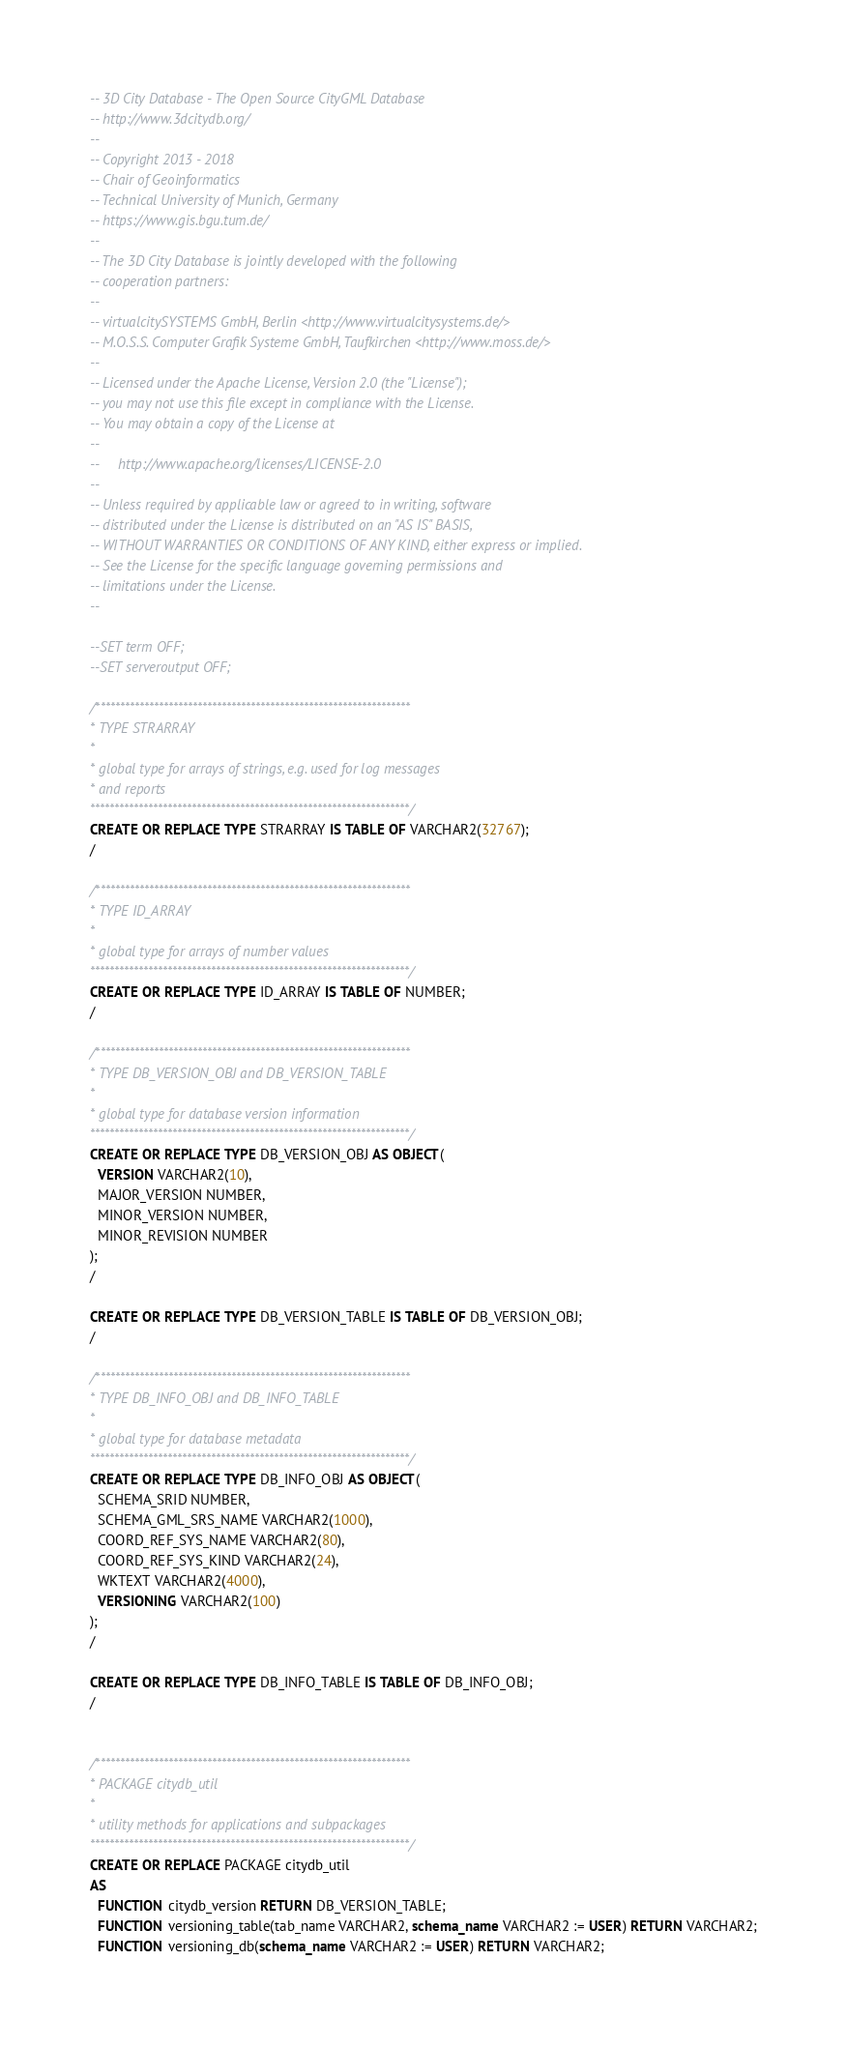<code> <loc_0><loc_0><loc_500><loc_500><_SQL_>-- 3D City Database - The Open Source CityGML Database
-- http://www.3dcitydb.org/
-- 
-- Copyright 2013 - 2018
-- Chair of Geoinformatics
-- Technical University of Munich, Germany
-- https://www.gis.bgu.tum.de/
-- 
-- The 3D City Database is jointly developed with the following
-- cooperation partners:
-- 
-- virtualcitySYSTEMS GmbH, Berlin <http://www.virtualcitysystems.de/>
-- M.O.S.S. Computer Grafik Systeme GmbH, Taufkirchen <http://www.moss.de/>
-- 
-- Licensed under the Apache License, Version 2.0 (the "License");
-- you may not use this file except in compliance with the License.
-- You may obtain a copy of the License at
-- 
--     http://www.apache.org/licenses/LICENSE-2.0
--     
-- Unless required by applicable law or agreed to in writing, software
-- distributed under the License is distributed on an "AS IS" BASIS,
-- WITHOUT WARRANTIES OR CONDITIONS OF ANY KIND, either express or implied.
-- See the License for the specific language governing permissions and
-- limitations under the License.
--

--SET term OFF;
--SET serveroutput OFF;

/*****************************************************************
* TYPE STRARRAY
*
* global type for arrays of strings, e.g. used for log messages
* and reports
******************************************************************/
CREATE OR REPLACE TYPE STRARRAY IS TABLE OF VARCHAR2(32767);
/

/*****************************************************************
* TYPE ID_ARRAY
*
* global type for arrays of number values
******************************************************************/
CREATE OR REPLACE TYPE ID_ARRAY IS TABLE OF NUMBER;
/

/*****************************************************************
* TYPE DB_VERSION_OBJ and DB_VERSION_TABLE
* 
* global type for database version information
******************************************************************/
CREATE OR REPLACE TYPE DB_VERSION_OBJ AS OBJECT(
  VERSION VARCHAR2(10),
  MAJOR_VERSION NUMBER,
  MINOR_VERSION NUMBER,
  MINOR_REVISION NUMBER
);
/

CREATE OR REPLACE TYPE DB_VERSION_TABLE IS TABLE OF DB_VERSION_OBJ;
/

/*****************************************************************
* TYPE DB_INFO_OBJ and DB_INFO_TABLE
* 
* global type for database metadata
******************************************************************/
CREATE OR REPLACE TYPE DB_INFO_OBJ AS OBJECT(
  SCHEMA_SRID NUMBER,
  SCHEMA_GML_SRS_NAME VARCHAR2(1000),
  COORD_REF_SYS_NAME VARCHAR2(80),
  COORD_REF_SYS_KIND VARCHAR2(24),
  WKTEXT VARCHAR2(4000),
  VERSIONING VARCHAR2(100)
);
/

CREATE OR REPLACE TYPE DB_INFO_TABLE IS TABLE OF DB_INFO_OBJ;
/


/*****************************************************************
* PACKAGE citydb_util
* 
* utility methods for applications and subpackages
******************************************************************/
CREATE OR REPLACE PACKAGE citydb_util
AS
  FUNCTION citydb_version RETURN DB_VERSION_TABLE;
  FUNCTION versioning_table(tab_name VARCHAR2, schema_name VARCHAR2 := USER) RETURN VARCHAR2;
  FUNCTION versioning_db(schema_name VARCHAR2 := USER) RETURN VARCHAR2;</code> 